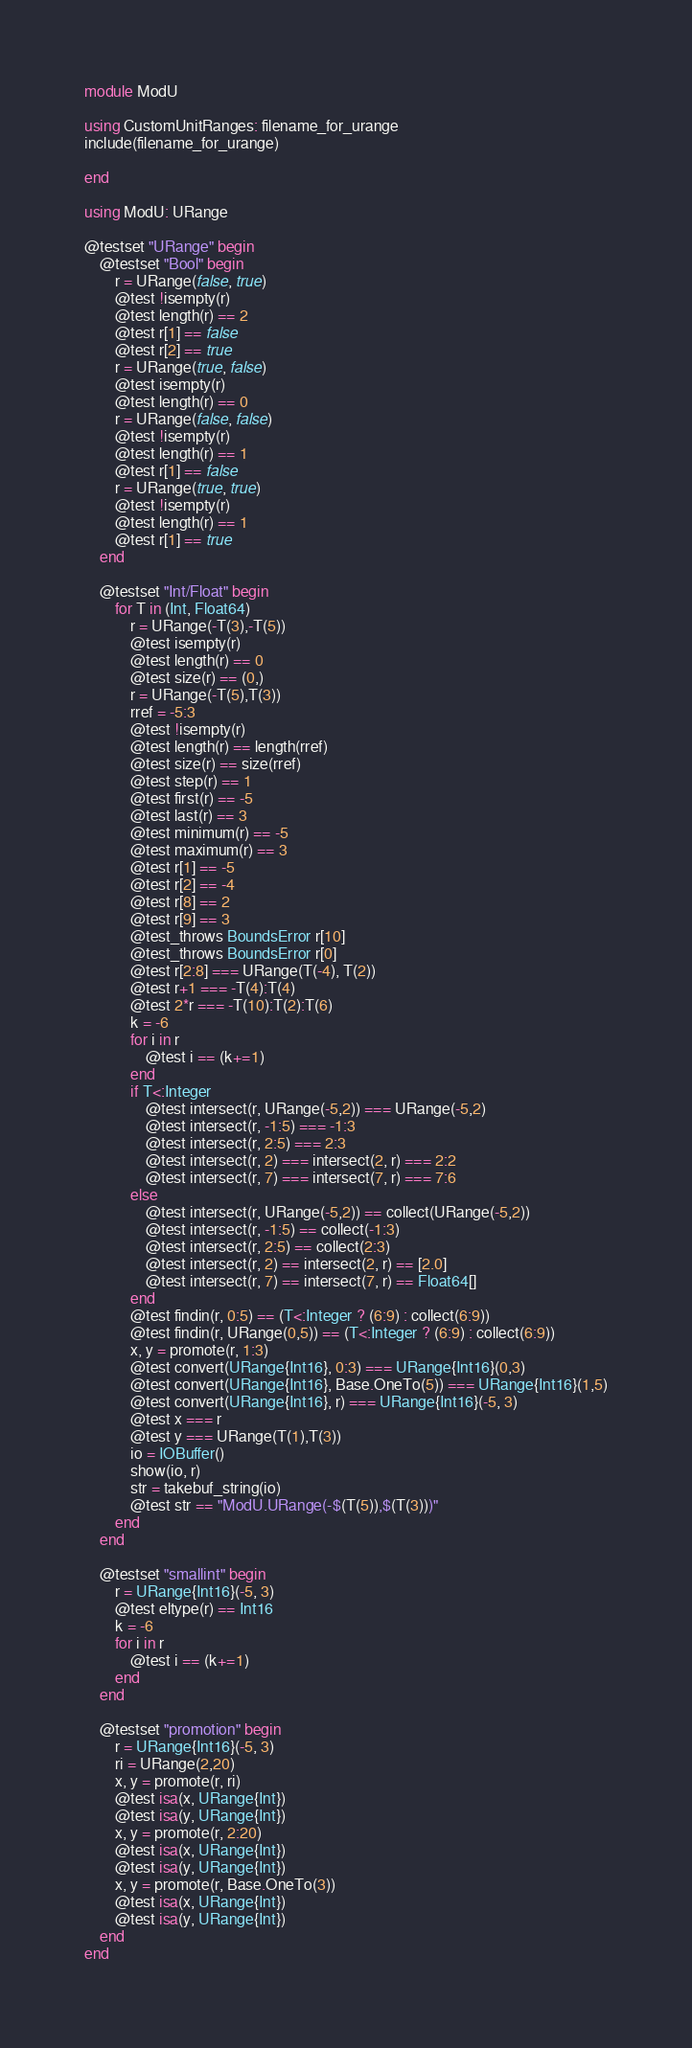<code> <loc_0><loc_0><loc_500><loc_500><_Julia_>module ModU

using CustomUnitRanges: filename_for_urange
include(filename_for_urange)

end

using ModU: URange

@testset "URange" begin
    @testset "Bool" begin
        r = URange(false, true)
        @test !isempty(r)
        @test length(r) == 2
        @test r[1] == false
        @test r[2] == true
        r = URange(true, false)
        @test isempty(r)
        @test length(r) == 0
        r = URange(false, false)
        @test !isempty(r)
        @test length(r) == 1
        @test r[1] == false
        r = URange(true, true)
        @test !isempty(r)
        @test length(r) == 1
        @test r[1] == true
    end

    @testset "Int/Float" begin
        for T in (Int, Float64)
            r = URange(-T(3),-T(5))
            @test isempty(r)
            @test length(r) == 0
            @test size(r) == (0,)
            r = URange(-T(5),T(3))
            rref = -5:3
            @test !isempty(r)
            @test length(r) == length(rref)
            @test size(r) == size(rref)
            @test step(r) == 1
            @test first(r) == -5
            @test last(r) == 3
            @test minimum(r) == -5
            @test maximum(r) == 3
            @test r[1] == -5
            @test r[2] == -4
            @test r[8] == 2
            @test r[9] == 3
            @test_throws BoundsError r[10]
            @test_throws BoundsError r[0]
            @test r[2:8] === URange(T(-4), T(2))
            @test r+1 === -T(4):T(4)
            @test 2*r === -T(10):T(2):T(6)
            k = -6
            for i in r
                @test i == (k+=1)
            end
            if T<:Integer
                @test intersect(r, URange(-5,2)) === URange(-5,2)
                @test intersect(r, -1:5) === -1:3
                @test intersect(r, 2:5) === 2:3
                @test intersect(r, 2) === intersect(2, r) === 2:2
                @test intersect(r, 7) === intersect(7, r) === 7:6
            else
                @test intersect(r, URange(-5,2)) == collect(URange(-5,2))
                @test intersect(r, -1:5) == collect(-1:3)
                @test intersect(r, 2:5) == collect(2:3)
                @test intersect(r, 2) == intersect(2, r) == [2.0]
                @test intersect(r, 7) == intersect(7, r) == Float64[]
            end
            @test findin(r, 0:5) == (T<:Integer ? (6:9) : collect(6:9))
            @test findin(r, URange(0,5)) == (T<:Integer ? (6:9) : collect(6:9))
            x, y = promote(r, 1:3)
            @test convert(URange{Int16}, 0:3) === URange{Int16}(0,3)
            @test convert(URange{Int16}, Base.OneTo(5)) === URange{Int16}(1,5)
            @test convert(URange{Int16}, r) === URange{Int16}(-5, 3)
            @test x === r
            @test y === URange(T(1),T(3))
            io = IOBuffer()
            show(io, r)
            str = takebuf_string(io)
            @test str == "ModU.URange(-$(T(5)),$(T(3)))"
        end
    end

    @testset "smallint" begin
        r = URange{Int16}(-5, 3)
        @test eltype(r) == Int16
        k = -6
        for i in r
            @test i == (k+=1)
        end
    end

    @testset "promotion" begin
        r = URange{Int16}(-5, 3)
        ri = URange(2,20)
        x, y = promote(r, ri)
        @test isa(x, URange{Int})
        @test isa(y, URange{Int})
        x, y = promote(r, 2:20)
        @test isa(x, URange{Int})
        @test isa(y, URange{Int})
        x, y = promote(r, Base.OneTo(3))
        @test isa(x, URange{Int})
        @test isa(y, URange{Int})
    end
end
</code> 